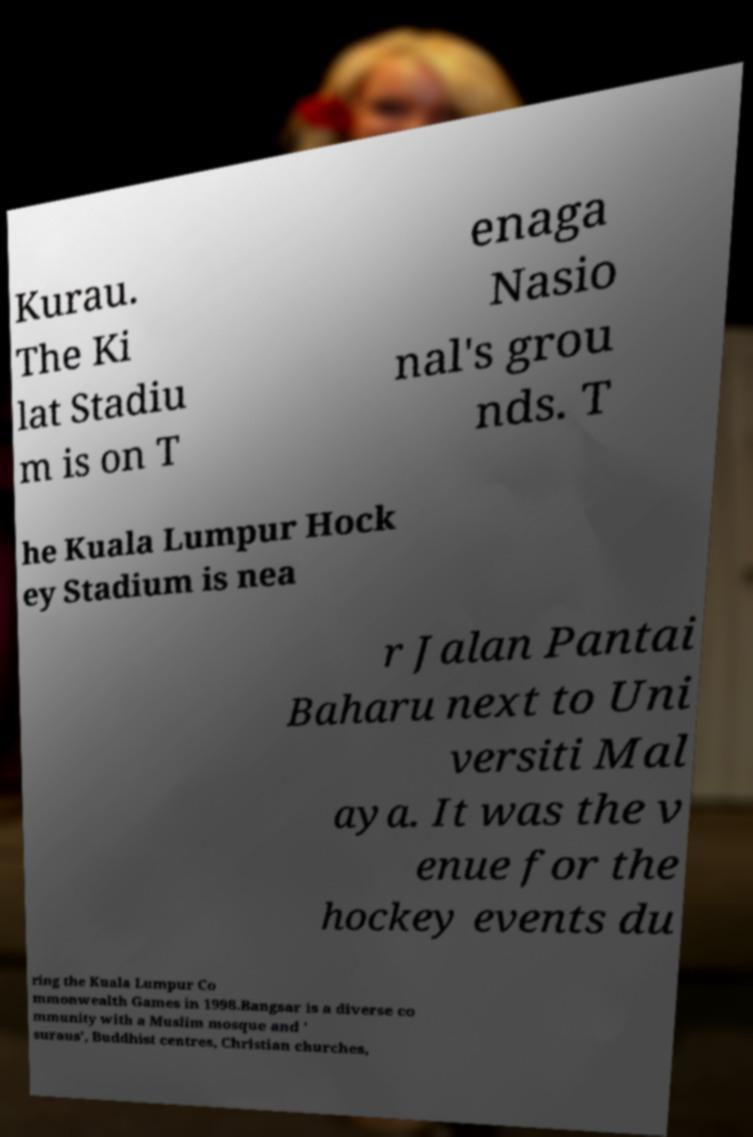Please identify and transcribe the text found in this image. Kurau. The Ki lat Stadiu m is on T enaga Nasio nal's grou nds. T he Kuala Lumpur Hock ey Stadium is nea r Jalan Pantai Baharu next to Uni versiti Mal aya. It was the v enue for the hockey events du ring the Kuala Lumpur Co mmonwealth Games in 1998.Bangsar is a diverse co mmunity with a Muslim mosque and ' suraus', Buddhist centres, Christian churches, 